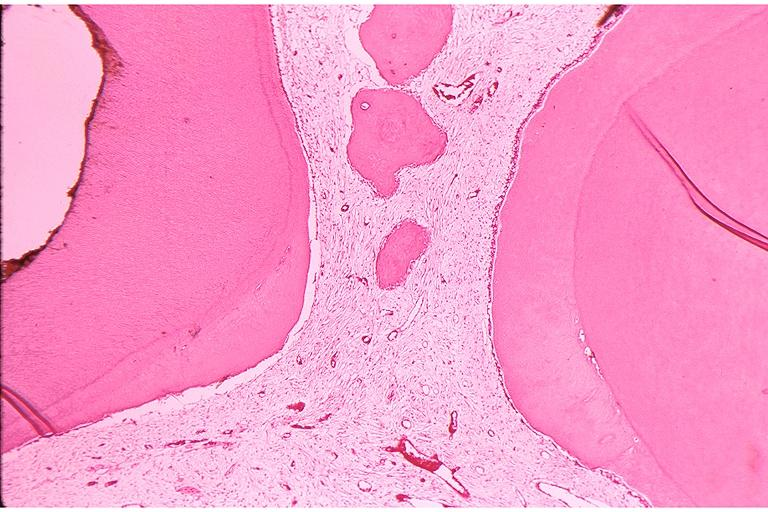what is present?
Answer the question using a single word or phrase. Oral 